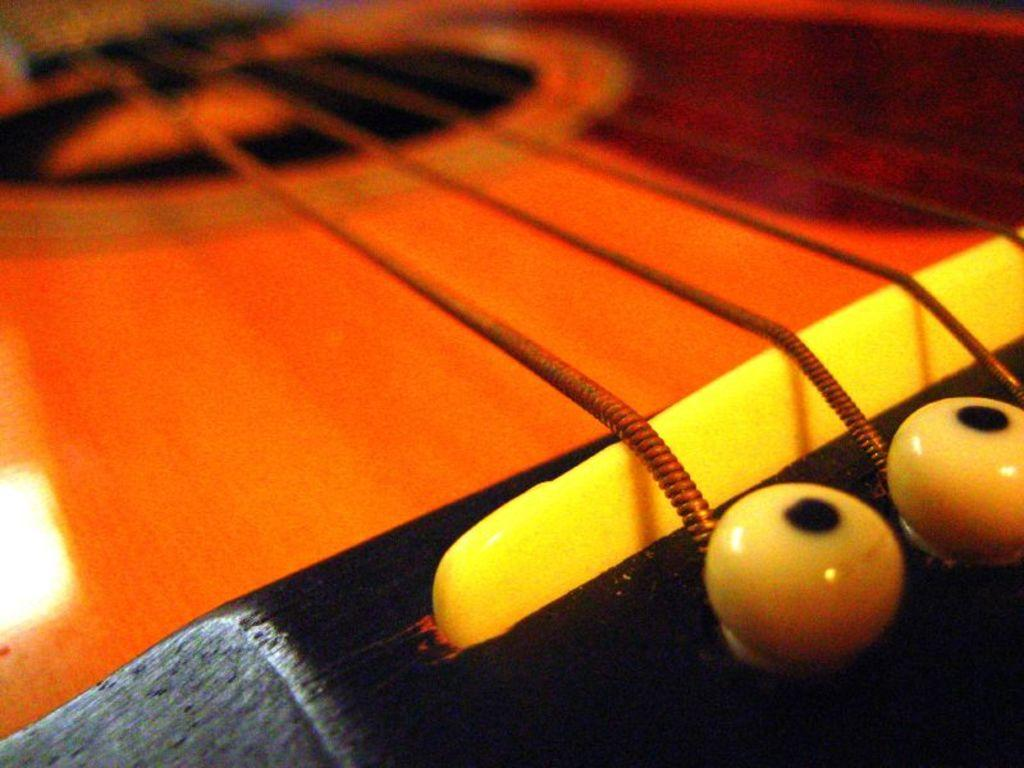What musical instrument is featured in the image? The image features the strings of a guitar. Can you describe the strings in more detail? The strings are the part of the guitar that produce sound when plucked or strummed. What reward does the passenger receive for holding the guitar's hand in the image? There is no passenger or hand holding the guitar in the image; it is simply a close-up of the strings. 